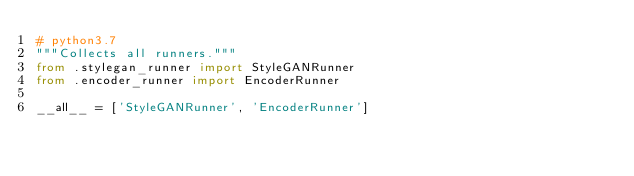Convert code to text. <code><loc_0><loc_0><loc_500><loc_500><_Python_># python3.7
"""Collects all runners."""
from .stylegan_runner import StyleGANRunner
from .encoder_runner import EncoderRunner

__all__ = ['StyleGANRunner', 'EncoderRunner']
</code> 